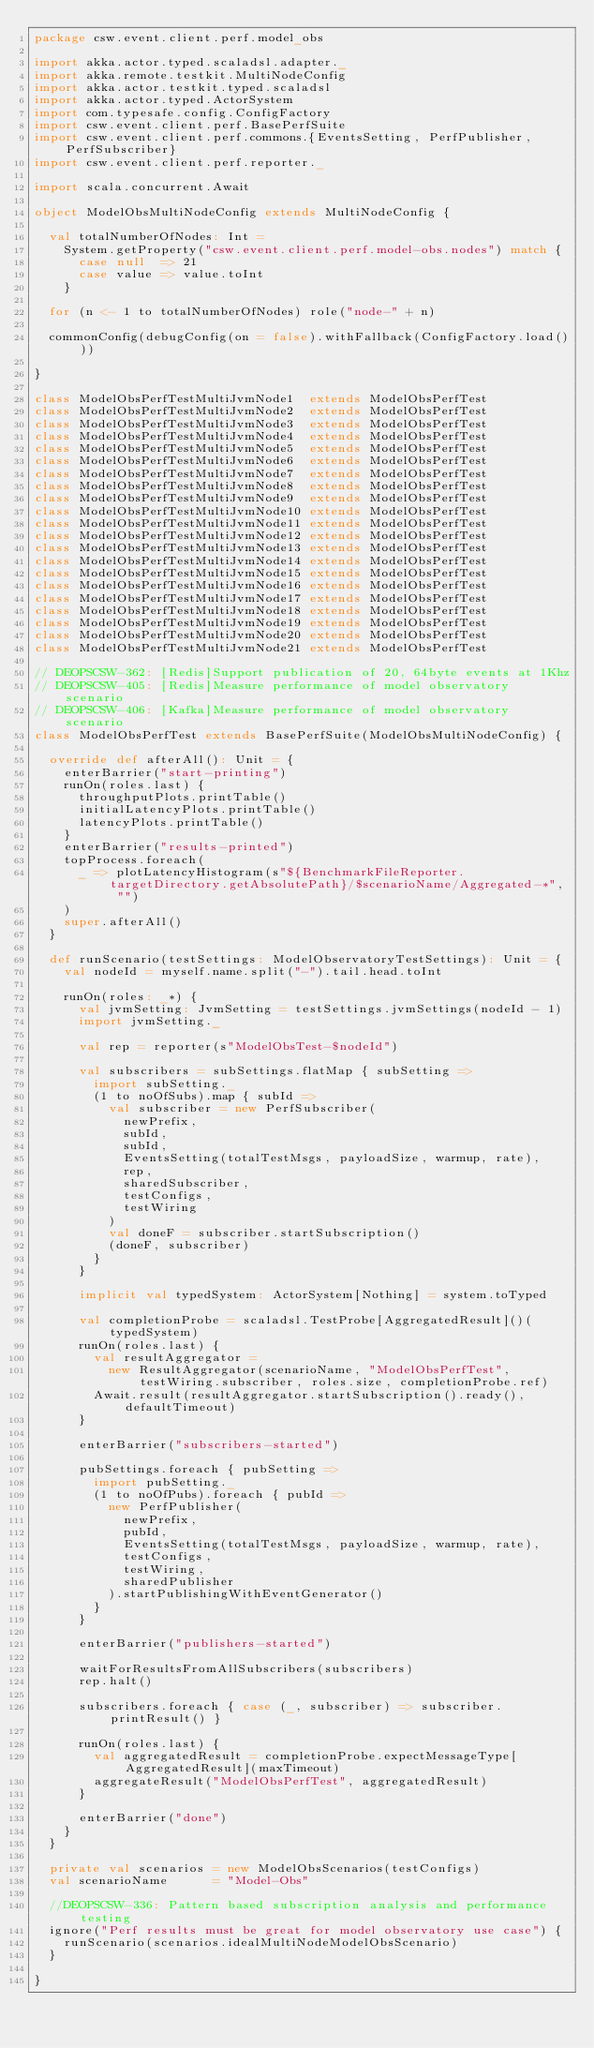<code> <loc_0><loc_0><loc_500><loc_500><_Scala_>package csw.event.client.perf.model_obs

import akka.actor.typed.scaladsl.adapter._
import akka.remote.testkit.MultiNodeConfig
import akka.actor.testkit.typed.scaladsl
import akka.actor.typed.ActorSystem
import com.typesafe.config.ConfigFactory
import csw.event.client.perf.BasePerfSuite
import csw.event.client.perf.commons.{EventsSetting, PerfPublisher, PerfSubscriber}
import csw.event.client.perf.reporter._

import scala.concurrent.Await

object ModelObsMultiNodeConfig extends MultiNodeConfig {

  val totalNumberOfNodes: Int =
    System.getProperty("csw.event.client.perf.model-obs.nodes") match {
      case null  => 21
      case value => value.toInt
    }

  for (n <- 1 to totalNumberOfNodes) role("node-" + n)

  commonConfig(debugConfig(on = false).withFallback(ConfigFactory.load()))

}

class ModelObsPerfTestMultiJvmNode1  extends ModelObsPerfTest
class ModelObsPerfTestMultiJvmNode2  extends ModelObsPerfTest
class ModelObsPerfTestMultiJvmNode3  extends ModelObsPerfTest
class ModelObsPerfTestMultiJvmNode4  extends ModelObsPerfTest
class ModelObsPerfTestMultiJvmNode5  extends ModelObsPerfTest
class ModelObsPerfTestMultiJvmNode6  extends ModelObsPerfTest
class ModelObsPerfTestMultiJvmNode7  extends ModelObsPerfTest
class ModelObsPerfTestMultiJvmNode8  extends ModelObsPerfTest
class ModelObsPerfTestMultiJvmNode9  extends ModelObsPerfTest
class ModelObsPerfTestMultiJvmNode10 extends ModelObsPerfTest
class ModelObsPerfTestMultiJvmNode11 extends ModelObsPerfTest
class ModelObsPerfTestMultiJvmNode12 extends ModelObsPerfTest
class ModelObsPerfTestMultiJvmNode13 extends ModelObsPerfTest
class ModelObsPerfTestMultiJvmNode14 extends ModelObsPerfTest
class ModelObsPerfTestMultiJvmNode15 extends ModelObsPerfTest
class ModelObsPerfTestMultiJvmNode16 extends ModelObsPerfTest
class ModelObsPerfTestMultiJvmNode17 extends ModelObsPerfTest
class ModelObsPerfTestMultiJvmNode18 extends ModelObsPerfTest
class ModelObsPerfTestMultiJvmNode19 extends ModelObsPerfTest
class ModelObsPerfTestMultiJvmNode20 extends ModelObsPerfTest
class ModelObsPerfTestMultiJvmNode21 extends ModelObsPerfTest

// DEOPSCSW-362: [Redis]Support publication of 20, 64byte events at 1Khz
// DEOPSCSW-405: [Redis]Measure performance of model observatory scenario
// DEOPSCSW-406: [Kafka]Measure performance of model observatory scenario
class ModelObsPerfTest extends BasePerfSuite(ModelObsMultiNodeConfig) {

  override def afterAll(): Unit = {
    enterBarrier("start-printing")
    runOn(roles.last) {
      throughputPlots.printTable()
      initialLatencyPlots.printTable()
      latencyPlots.printTable()
    }
    enterBarrier("results-printed")
    topProcess.foreach(
      _ => plotLatencyHistogram(s"${BenchmarkFileReporter.targetDirectory.getAbsolutePath}/$scenarioName/Aggregated-*", "")
    )
    super.afterAll()
  }

  def runScenario(testSettings: ModelObservatoryTestSettings): Unit = {
    val nodeId = myself.name.split("-").tail.head.toInt

    runOn(roles: _*) {
      val jvmSetting: JvmSetting = testSettings.jvmSettings(nodeId - 1)
      import jvmSetting._

      val rep = reporter(s"ModelObsTest-$nodeId")

      val subscribers = subSettings.flatMap { subSetting =>
        import subSetting._
        (1 to noOfSubs).map { subId =>
          val subscriber = new PerfSubscriber(
            newPrefix,
            subId,
            subId,
            EventsSetting(totalTestMsgs, payloadSize, warmup, rate),
            rep,
            sharedSubscriber,
            testConfigs,
            testWiring
          )
          val doneF = subscriber.startSubscription()
          (doneF, subscriber)
        }
      }

      implicit val typedSystem: ActorSystem[Nothing] = system.toTyped

      val completionProbe = scaladsl.TestProbe[AggregatedResult]()(typedSystem)
      runOn(roles.last) {
        val resultAggregator =
          new ResultAggregator(scenarioName, "ModelObsPerfTest", testWiring.subscriber, roles.size, completionProbe.ref)
        Await.result(resultAggregator.startSubscription().ready(), defaultTimeout)
      }

      enterBarrier("subscribers-started")

      pubSettings.foreach { pubSetting =>
        import pubSetting._
        (1 to noOfPubs).foreach { pubId =>
          new PerfPublisher(
            newPrefix,
            pubId,
            EventsSetting(totalTestMsgs, payloadSize, warmup, rate),
            testConfigs,
            testWiring,
            sharedPublisher
          ).startPublishingWithEventGenerator()
        }
      }

      enterBarrier("publishers-started")

      waitForResultsFromAllSubscribers(subscribers)
      rep.halt()

      subscribers.foreach { case (_, subscriber) => subscriber.printResult() }

      runOn(roles.last) {
        val aggregatedResult = completionProbe.expectMessageType[AggregatedResult](maxTimeout)
        aggregateResult("ModelObsPerfTest", aggregatedResult)
      }

      enterBarrier("done")
    }
  }

  private val scenarios = new ModelObsScenarios(testConfigs)
  val scenarioName      = "Model-Obs"

  //DEOPSCSW-336: Pattern based subscription analysis and performance testing
  ignore("Perf results must be great for model observatory use case") {
    runScenario(scenarios.idealMultiNodeModelObsScenario)
  }

}
</code> 